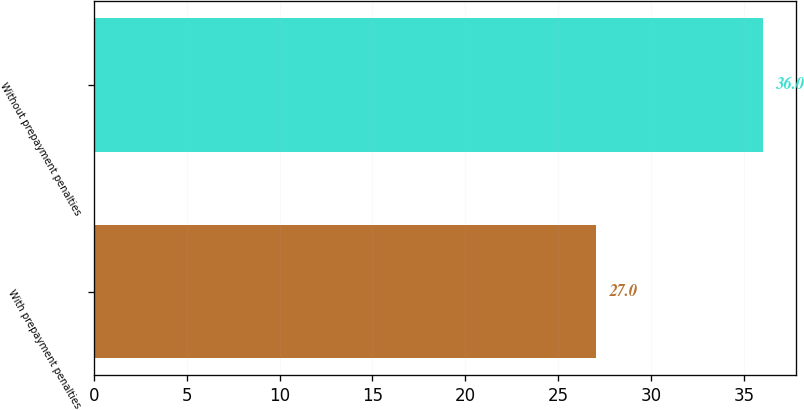<chart> <loc_0><loc_0><loc_500><loc_500><bar_chart><fcel>With prepayment penalties<fcel>Without prepayment penalties<nl><fcel>27<fcel>36<nl></chart> 